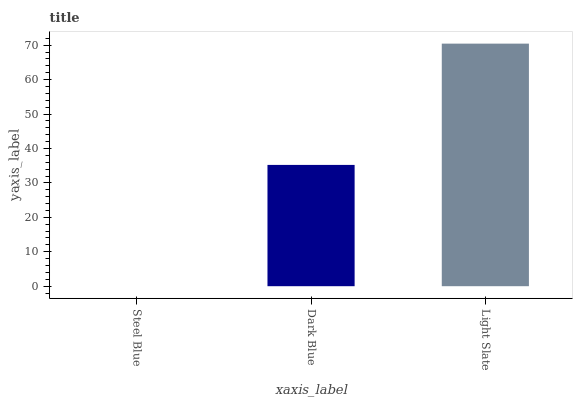Is Steel Blue the minimum?
Answer yes or no. Yes. Is Light Slate the maximum?
Answer yes or no. Yes. Is Dark Blue the minimum?
Answer yes or no. No. Is Dark Blue the maximum?
Answer yes or no. No. Is Dark Blue greater than Steel Blue?
Answer yes or no. Yes. Is Steel Blue less than Dark Blue?
Answer yes or no. Yes. Is Steel Blue greater than Dark Blue?
Answer yes or no. No. Is Dark Blue less than Steel Blue?
Answer yes or no. No. Is Dark Blue the high median?
Answer yes or no. Yes. Is Dark Blue the low median?
Answer yes or no. Yes. Is Steel Blue the high median?
Answer yes or no. No. Is Steel Blue the low median?
Answer yes or no. No. 